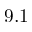<formula> <loc_0><loc_0><loc_500><loc_500>9 . 1</formula> 